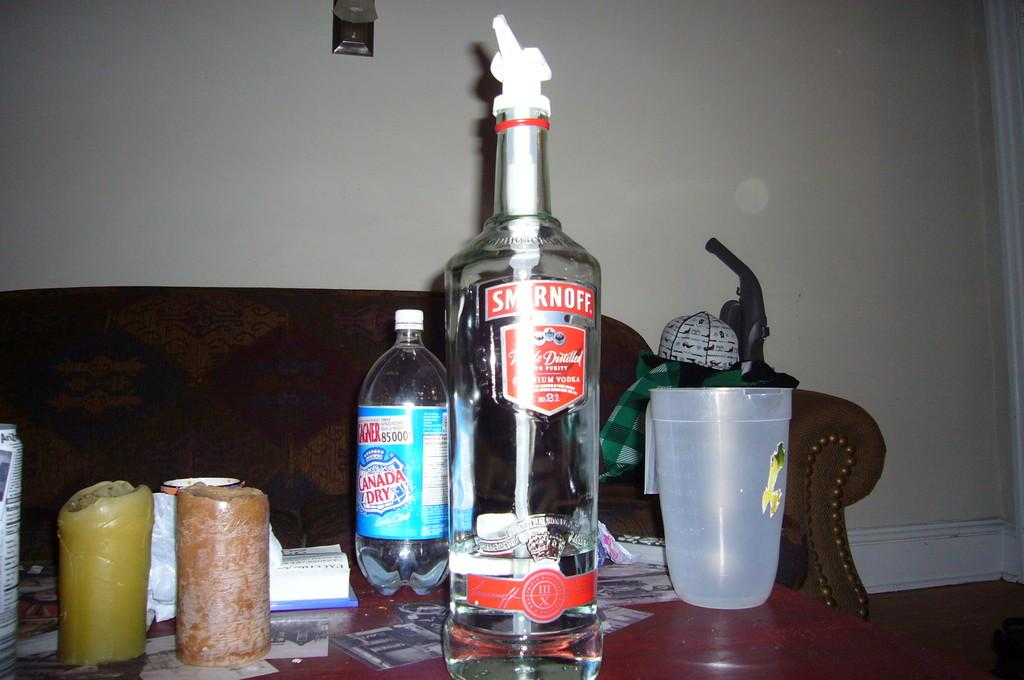<image>
Provide a brief description of the given image. a bottle of canada dry next to a bottle of smirnoff on a table 